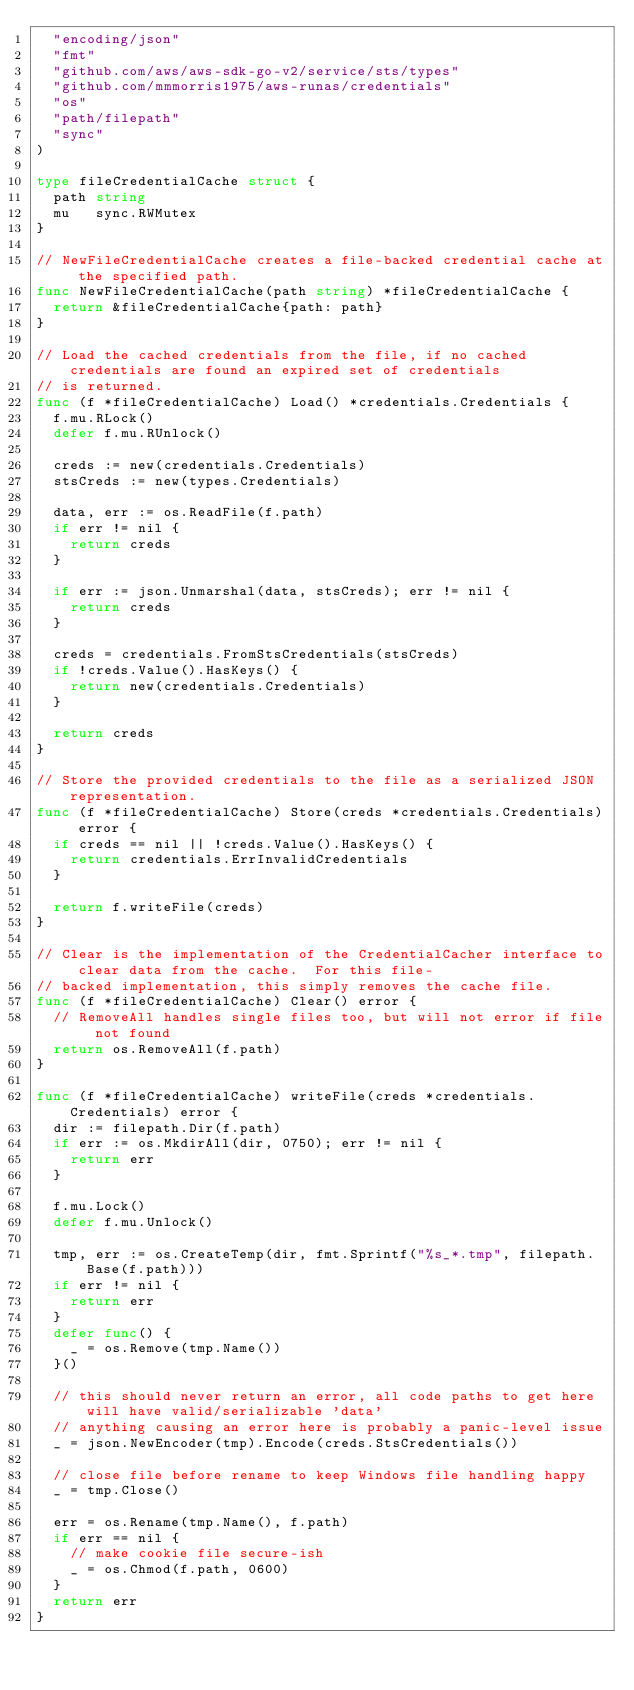<code> <loc_0><loc_0><loc_500><loc_500><_Go_>	"encoding/json"
	"fmt"
	"github.com/aws/aws-sdk-go-v2/service/sts/types"
	"github.com/mmmorris1975/aws-runas/credentials"
	"os"
	"path/filepath"
	"sync"
)

type fileCredentialCache struct {
	path string
	mu   sync.RWMutex
}

// NewFileCredentialCache creates a file-backed credential cache at the specified path.
func NewFileCredentialCache(path string) *fileCredentialCache {
	return &fileCredentialCache{path: path}
}

// Load the cached credentials from the file, if no cached credentials are found an expired set of credentials
// is returned.
func (f *fileCredentialCache) Load() *credentials.Credentials {
	f.mu.RLock()
	defer f.mu.RUnlock()

	creds := new(credentials.Credentials)
	stsCreds := new(types.Credentials)

	data, err := os.ReadFile(f.path)
	if err != nil {
		return creds
	}

	if err := json.Unmarshal(data, stsCreds); err != nil {
		return creds
	}

	creds = credentials.FromStsCredentials(stsCreds)
	if !creds.Value().HasKeys() {
		return new(credentials.Credentials)
	}

	return creds
}

// Store the provided credentials to the file as a serialized JSON representation.
func (f *fileCredentialCache) Store(creds *credentials.Credentials) error {
	if creds == nil || !creds.Value().HasKeys() {
		return credentials.ErrInvalidCredentials
	}

	return f.writeFile(creds)
}

// Clear is the implementation of the CredentialCacher interface to clear data from the cache.  For this file-
// backed implementation, this simply removes the cache file.
func (f *fileCredentialCache) Clear() error {
	// RemoveAll handles single files too, but will not error if file not found
	return os.RemoveAll(f.path)
}

func (f *fileCredentialCache) writeFile(creds *credentials.Credentials) error {
	dir := filepath.Dir(f.path)
	if err := os.MkdirAll(dir, 0750); err != nil {
		return err
	}

	f.mu.Lock()
	defer f.mu.Unlock()

	tmp, err := os.CreateTemp(dir, fmt.Sprintf("%s_*.tmp", filepath.Base(f.path)))
	if err != nil {
		return err
	}
	defer func() {
		_ = os.Remove(tmp.Name())
	}()

	// this should never return an error, all code paths to get here will have valid/serializable 'data'
	// anything causing an error here is probably a panic-level issue
	_ = json.NewEncoder(tmp).Encode(creds.StsCredentials())

	// close file before rename to keep Windows file handling happy
	_ = tmp.Close()

	err = os.Rename(tmp.Name(), f.path)
	if err == nil {
		// make cookie file secure-ish
		_ = os.Chmod(f.path, 0600)
	}
	return err
}
</code> 